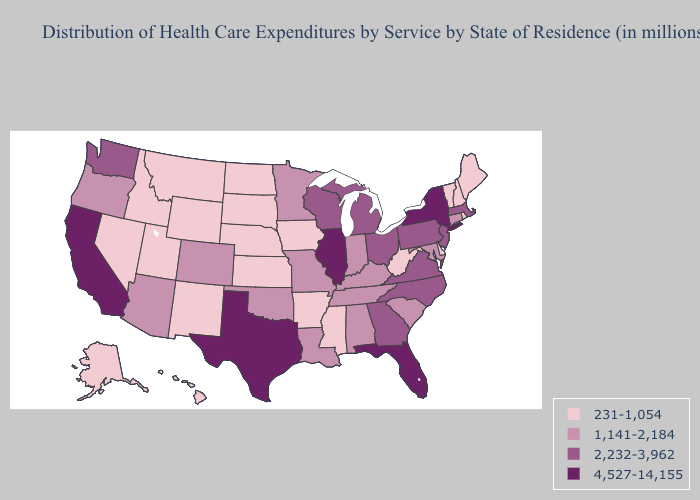What is the lowest value in states that border Kentucky?
Answer briefly. 231-1,054. What is the lowest value in the Northeast?
Write a very short answer. 231-1,054. Name the states that have a value in the range 4,527-14,155?
Write a very short answer. California, Florida, Illinois, New York, Texas. What is the value of Arkansas?
Answer briefly. 231-1,054. Name the states that have a value in the range 1,141-2,184?
Concise answer only. Alabama, Arizona, Colorado, Connecticut, Indiana, Kentucky, Louisiana, Maryland, Minnesota, Missouri, Oklahoma, Oregon, South Carolina, Tennessee. Which states have the lowest value in the USA?
Be succinct. Alaska, Arkansas, Delaware, Hawaii, Idaho, Iowa, Kansas, Maine, Mississippi, Montana, Nebraska, Nevada, New Hampshire, New Mexico, North Dakota, Rhode Island, South Dakota, Utah, Vermont, West Virginia, Wyoming. What is the value of Hawaii?
Be succinct. 231-1,054. Does the first symbol in the legend represent the smallest category?
Be succinct. Yes. Name the states that have a value in the range 231-1,054?
Be succinct. Alaska, Arkansas, Delaware, Hawaii, Idaho, Iowa, Kansas, Maine, Mississippi, Montana, Nebraska, Nevada, New Hampshire, New Mexico, North Dakota, Rhode Island, South Dakota, Utah, Vermont, West Virginia, Wyoming. Among the states that border Minnesota , which have the highest value?
Write a very short answer. Wisconsin. Name the states that have a value in the range 4,527-14,155?
Write a very short answer. California, Florida, Illinois, New York, Texas. Name the states that have a value in the range 1,141-2,184?
Short answer required. Alabama, Arizona, Colorado, Connecticut, Indiana, Kentucky, Louisiana, Maryland, Minnesota, Missouri, Oklahoma, Oregon, South Carolina, Tennessee. What is the lowest value in the West?
Keep it brief. 231-1,054. Name the states that have a value in the range 2,232-3,962?
Write a very short answer. Georgia, Massachusetts, Michigan, New Jersey, North Carolina, Ohio, Pennsylvania, Virginia, Washington, Wisconsin. How many symbols are there in the legend?
Short answer required. 4. 